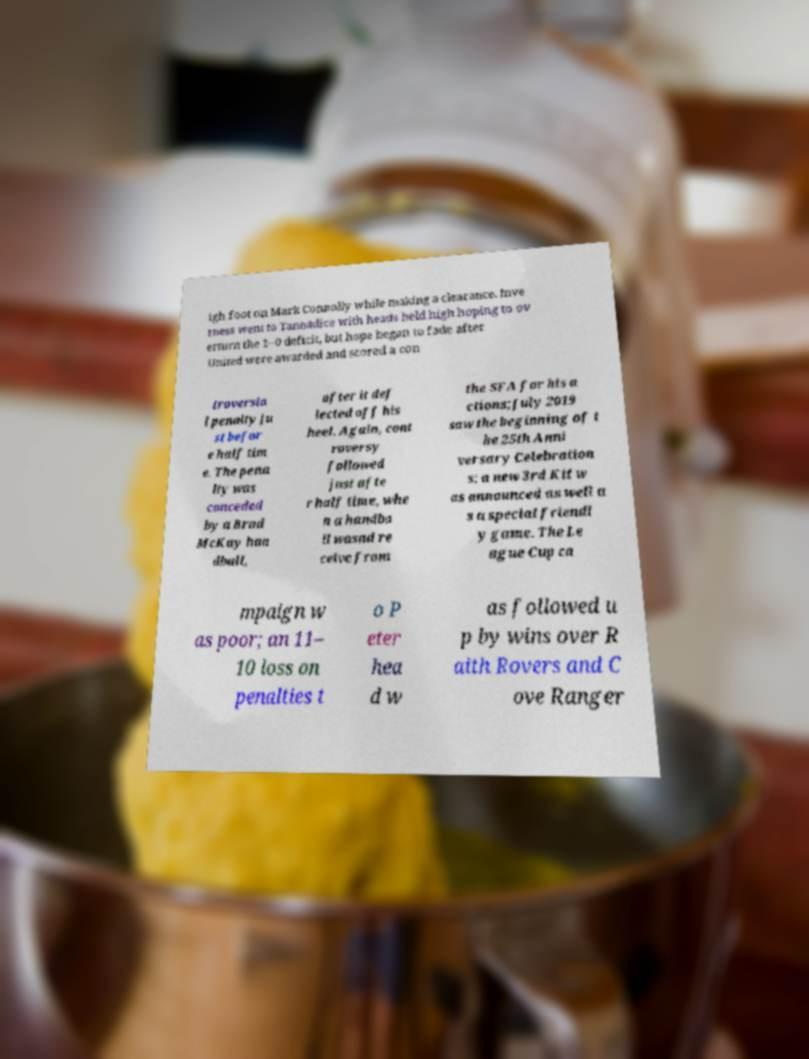What messages or text are displayed in this image? I need them in a readable, typed format. igh foot on Mark Connolly while making a clearance. Inve rness went to Tannadice with heads held high hoping to ov erturn the 1–0 deficit, but hope began to fade after United were awarded and scored a con troversia l penalty ju st befor e half tim e. The pena lty was conceded by a Brad McKay han dball, after it def lected off his heel. Again, cont roversy followed just afte r half time, whe n a handba ll wasnd re ceive from the SFA for his a ctions;July 2019 saw the beginning of t he 25th Anni versary Celebration s: a new 3rd Kit w as announced as well a s a special friendl y game. The Le ague Cup ca mpaign w as poor; an 11– 10 loss on penalties t o P eter hea d w as followed u p by wins over R aith Rovers and C ove Ranger 